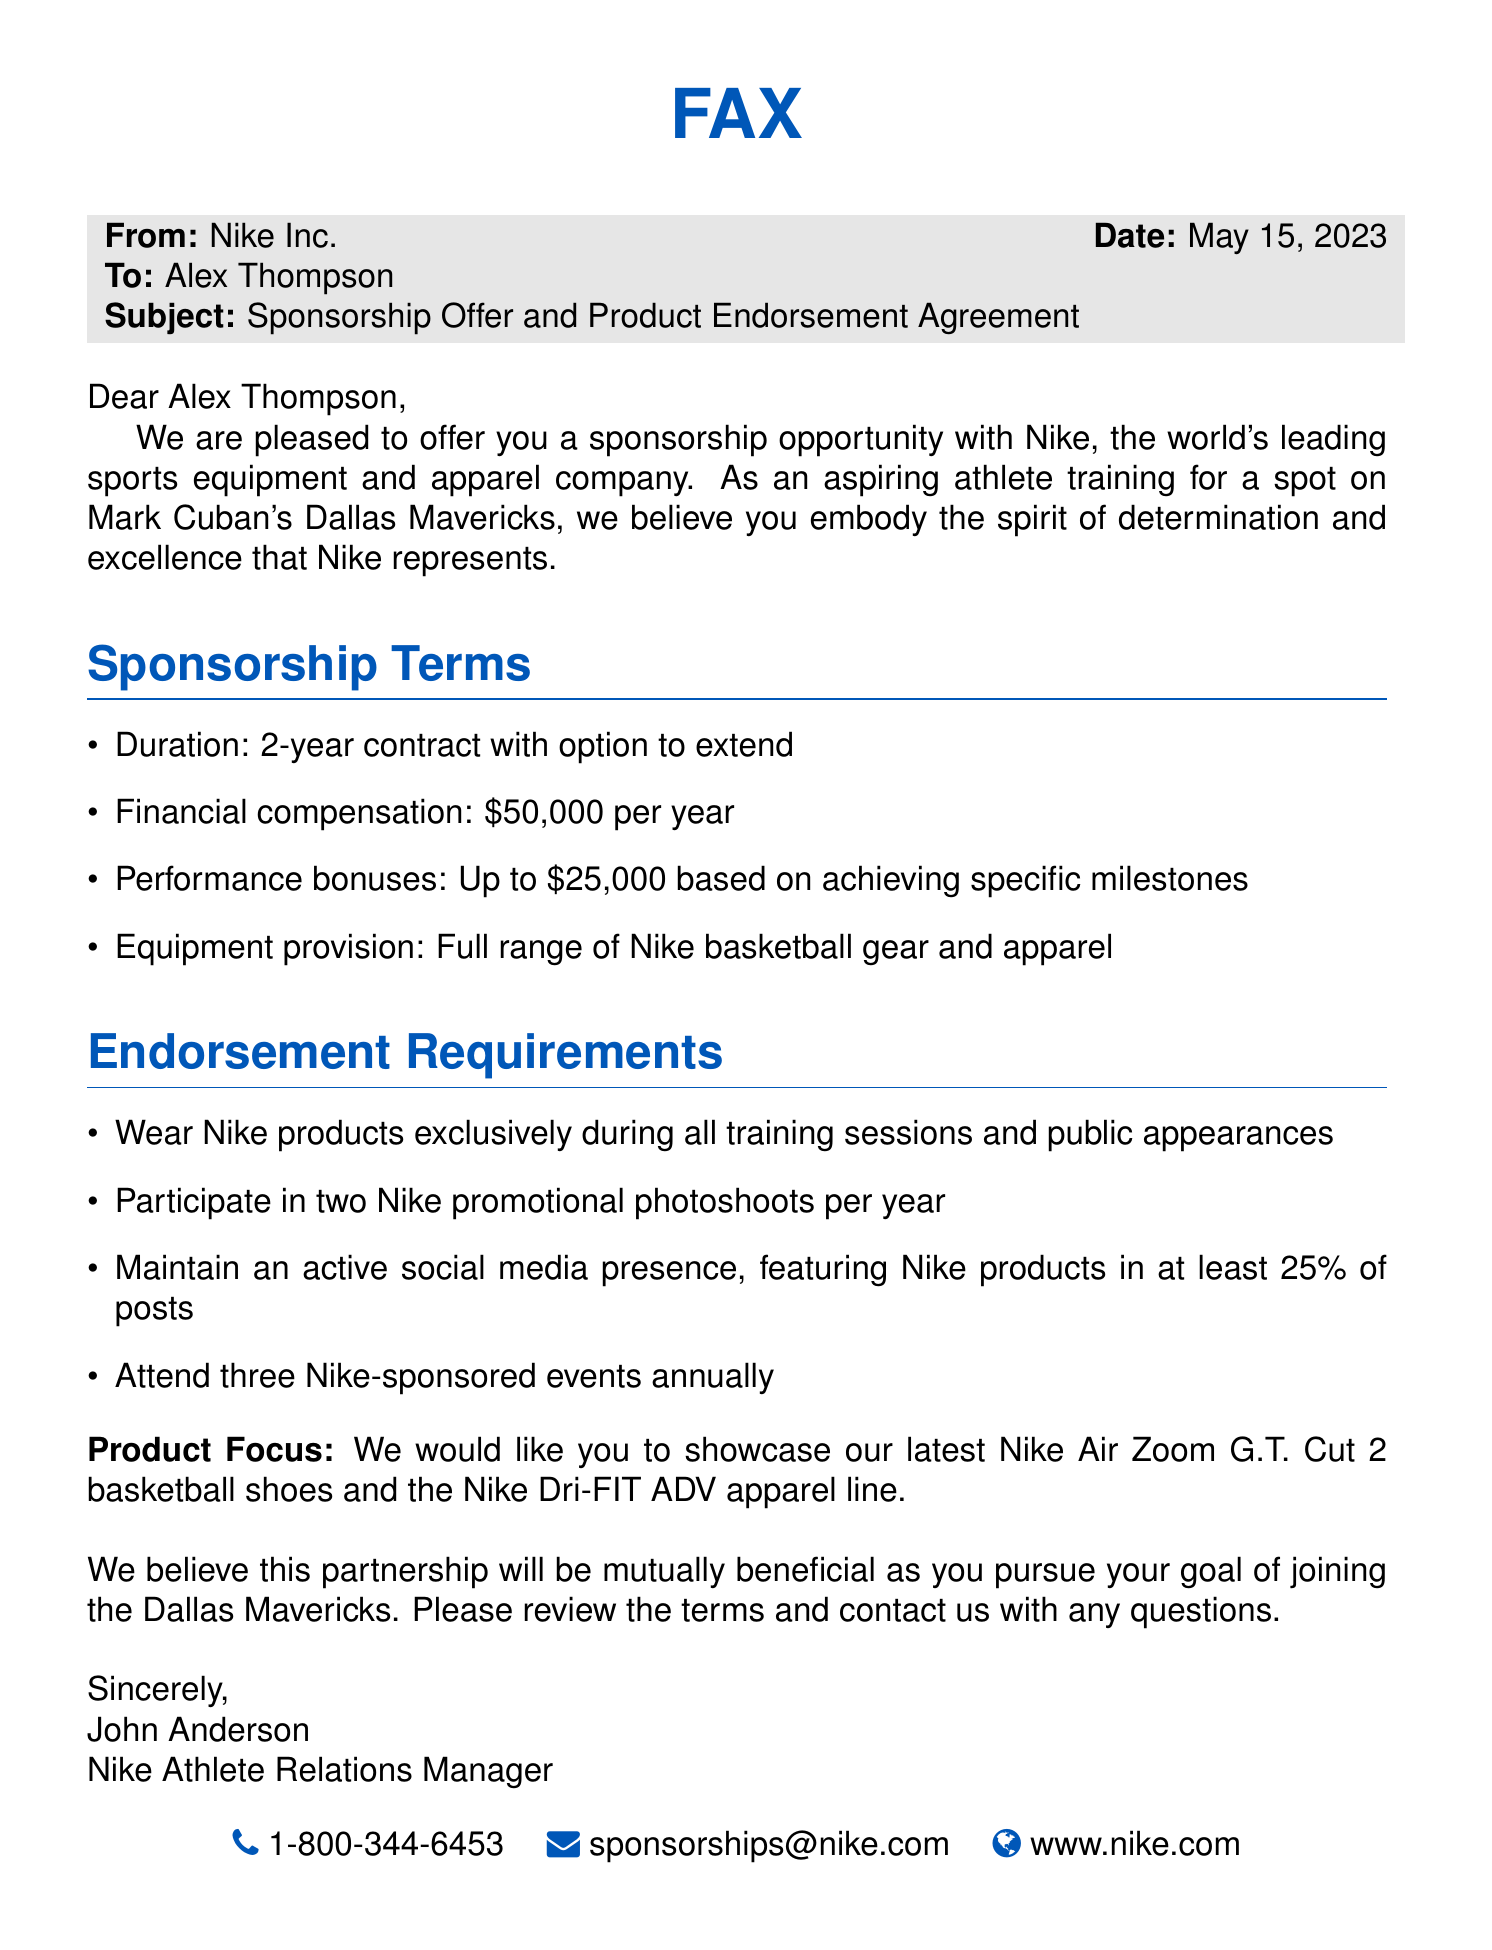What is the name of the athlete receiving the sponsorship offer? The name of the athlete is mentioned in the document as "Alex Thompson."
Answer: Alex Thompson What is the duration of the contract? The document specifies that the duration of the contract is "2-year contract."
Answer: 2-year What is the annual financial compensation amount? According to the document, the financial compensation is stated as "$50,000 per year."
Answer: $50,000 What type of events must the athlete attend annually? The document indicates that the athlete must attend "three Nike-sponsored events annually."
Answer: three Nike-sponsored events How often must the athlete participate in promotional photoshoots? The requirement states that the athlete must participate in "two Nike promotional photoshoots per year."
Answer: two What percentage of social media posts must feature Nike products? The document specifies that at least "25% of posts" must feature Nike products.
Answer: 25% Which specific Nike product lines are to be showcased? The document mentions that the athlete should showcase "Nike Air Zoom G.T. Cut 2 basketball shoes" and "Nike Dri-FIT ADV apparel line."
Answer: Nike Air Zoom G.T. Cut 2 basketball shoes and Nike Dri-FIT ADV apparel line Who is the sender of the fax? The sender of the fax is identified in the document as "John Anderson."
Answer: John Anderson What is the contact email for sponsorship inquiries? The document provides the contact email as "sponsorships@nike.com."
Answer: sponsorships@nike.com 